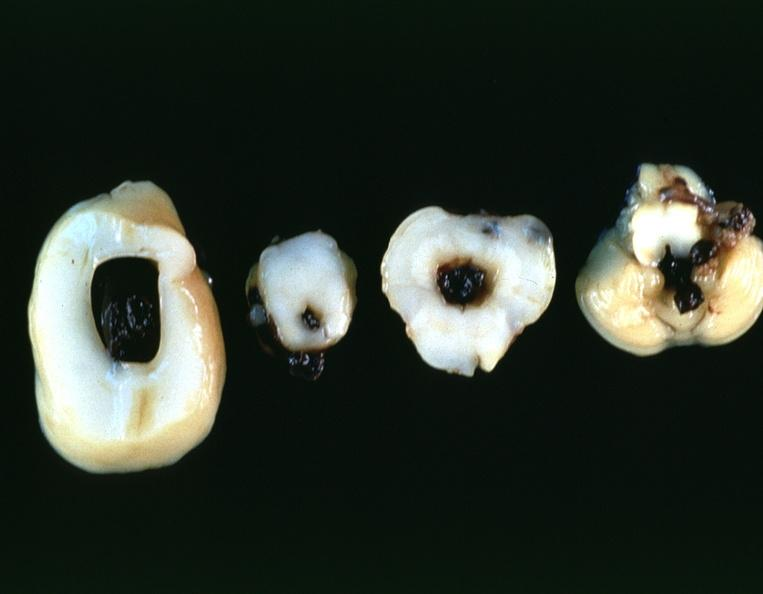what does this image show?
Answer the question using a single word or phrase. Brain 